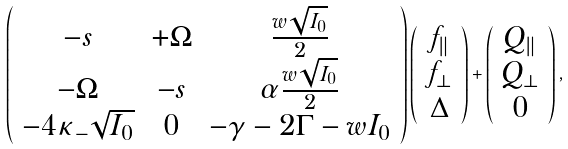<formula> <loc_0><loc_0><loc_500><loc_500>\left ( \begin{array} { c c c } - s & + \Omega & \frac { w \sqrt { I _ { 0 } } } { 2 } \\ - \Omega & - s & \alpha \frac { w \sqrt { I _ { 0 } } } { 2 } \\ - 4 \kappa _ { - } \sqrt { I _ { 0 } } & 0 & - \gamma - 2 \Gamma - w I _ { 0 } \end{array} \right ) \left ( \begin{array} { c } f _ { \| } \\ f _ { \perp } \\ \Delta \end{array} \right ) + \left ( \begin{array} { c } Q _ { \| } \\ Q _ { \perp } \\ 0 \end{array} \right ) ,</formula> 